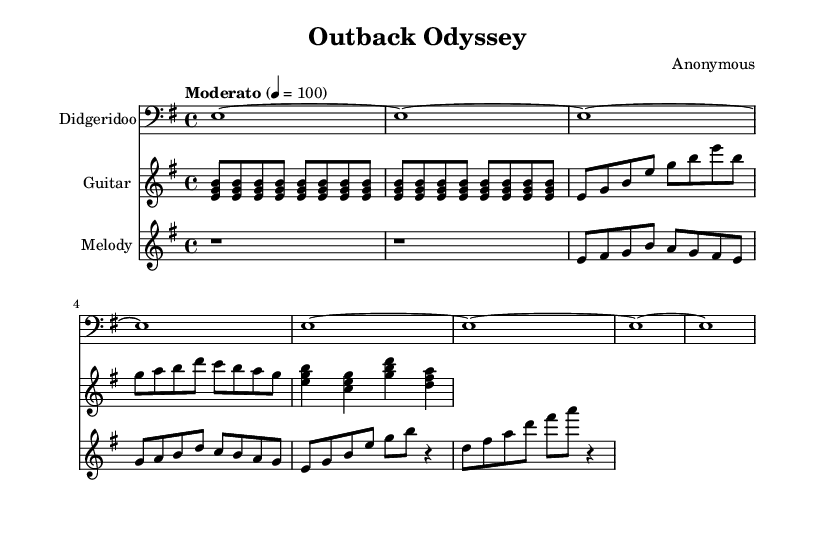What is the key signature of this music? The key signature is indicated by the presence of the sharp signs. In this case, it is E minor, which has one sharp.
Answer: E minor What is the time signature of this music? The time signature is indicated at the beginning of the score and is shown as 4/4, meaning there are four beats per measure, and each beat is a quarter note.
Answer: 4/4 What is the tempo marking for this piece? The tempo marking indicates the speed of the music and is stated in beats per minute. Here, it is set to Moderato at 100 beats per minute.
Answer: Moderato 100 How many measures are in the didgeridoo part? By counting the measures in the didgeridoo music section, there are eight measures total, indicated by the repeating patterns of notes.
Answer: 8 What type of instrument is featured in the second staff? The second staff is labeled as "Guitar," indicating the type of instrument being played.
Answer: Guitar Which note appears first in the melody music? The first note in the melody music section is a rest (indicated by the 'r'), which signifies a pause before the melodic activity begins.
Answer: Rest How many different pitches are represented in the guitar music? Counting the distinct pitches noted in the guitar music shows that there are seven different pitches, which can be found in the chord formations and individual notes.
Answer: 7 